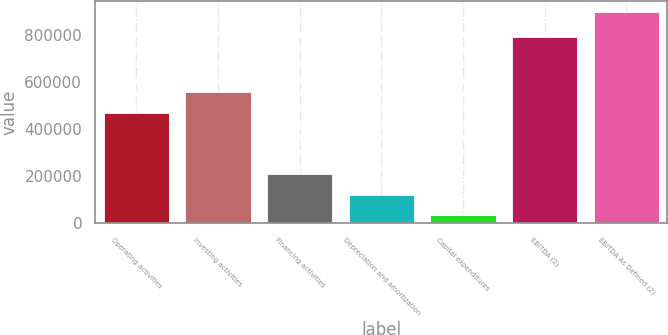Convert chart. <chart><loc_0><loc_0><loc_500><loc_500><bar_chart><fcel>Operating activities<fcel>Investing activities<fcel>Financing activities<fcel>Depreciation and amortization<fcel>Capital expenditures<fcel>EBITDA (2)<fcel>EBITDA As Defined (2)<nl><fcel>470205<fcel>556679<fcel>208484<fcel>122009<fcel>35535<fcel>792689<fcel>900278<nl></chart> 